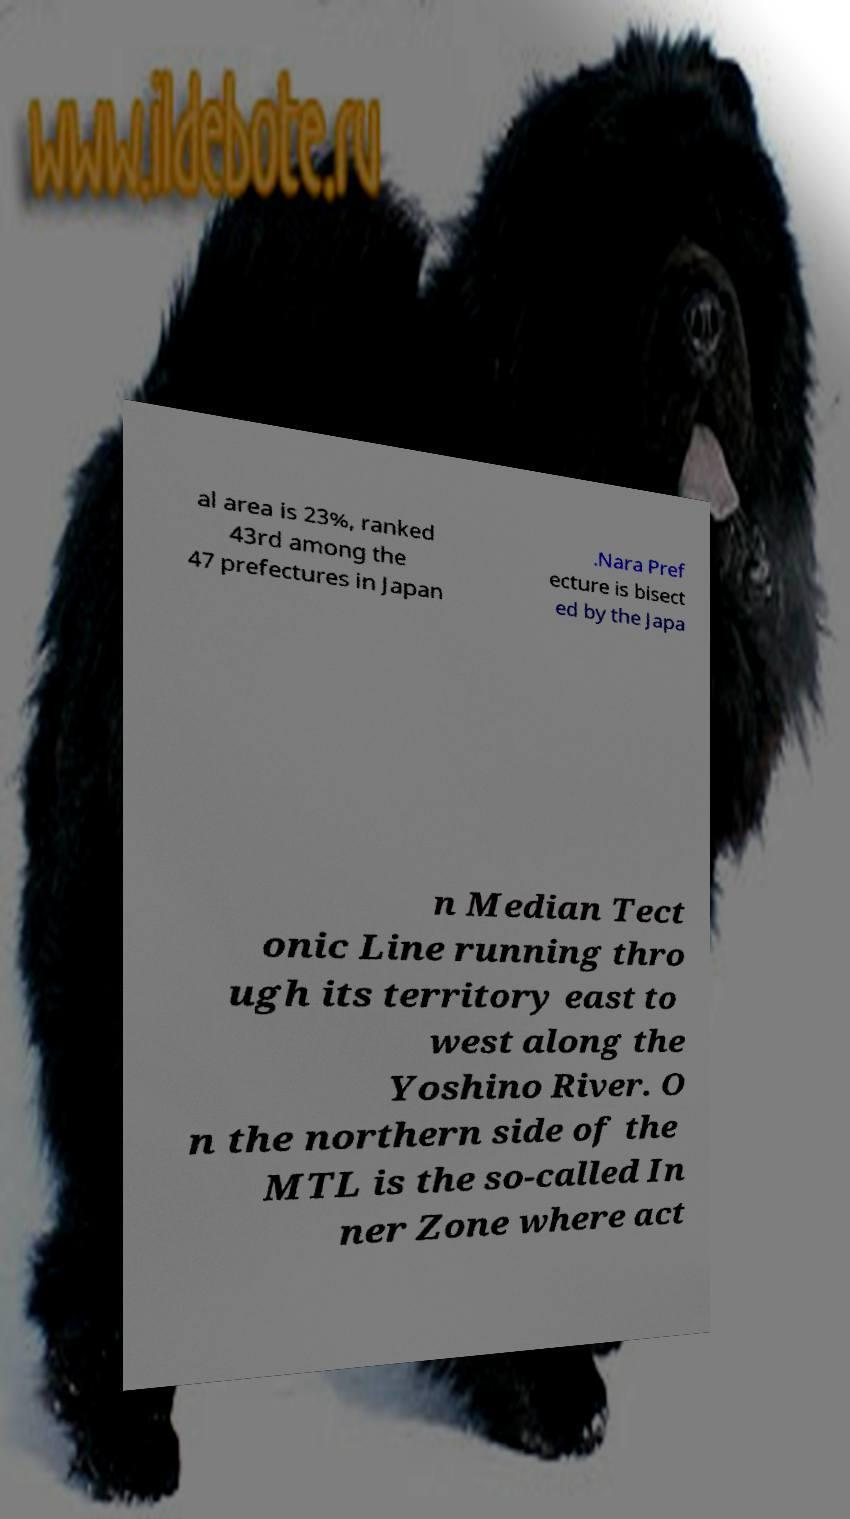There's text embedded in this image that I need extracted. Can you transcribe it verbatim? al area is 23%, ranked 43rd among the 47 prefectures in Japan .Nara Pref ecture is bisect ed by the Japa n Median Tect onic Line running thro ugh its territory east to west along the Yoshino River. O n the northern side of the MTL is the so-called In ner Zone where act 